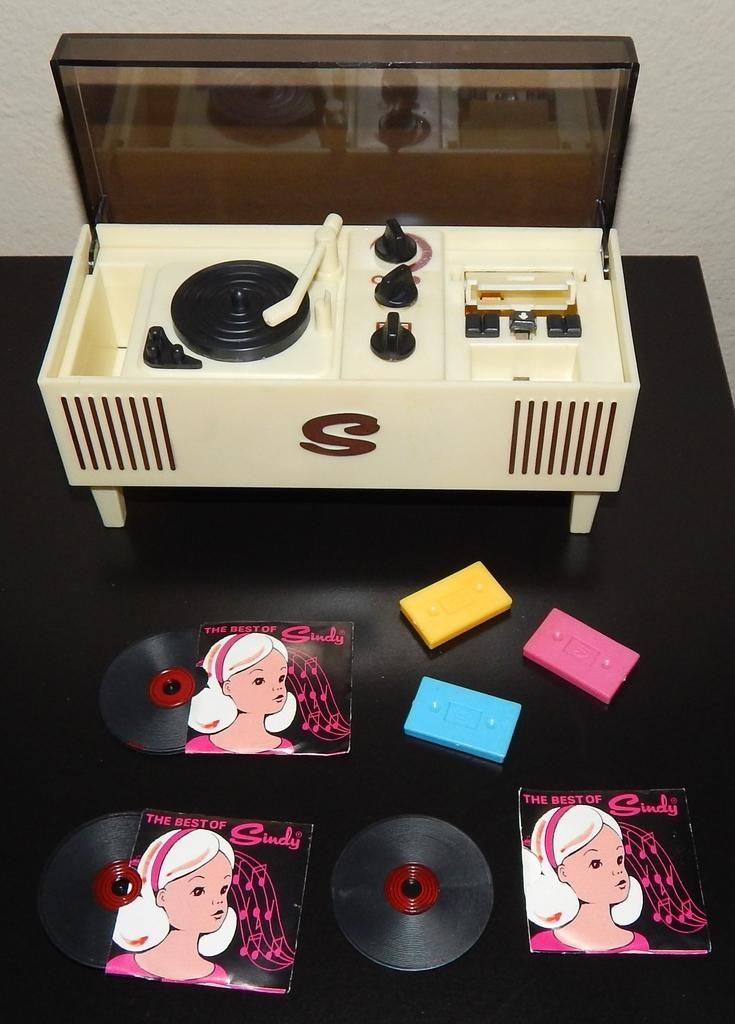<image>
Describe the image concisely. the letter S is on the machine that is white 